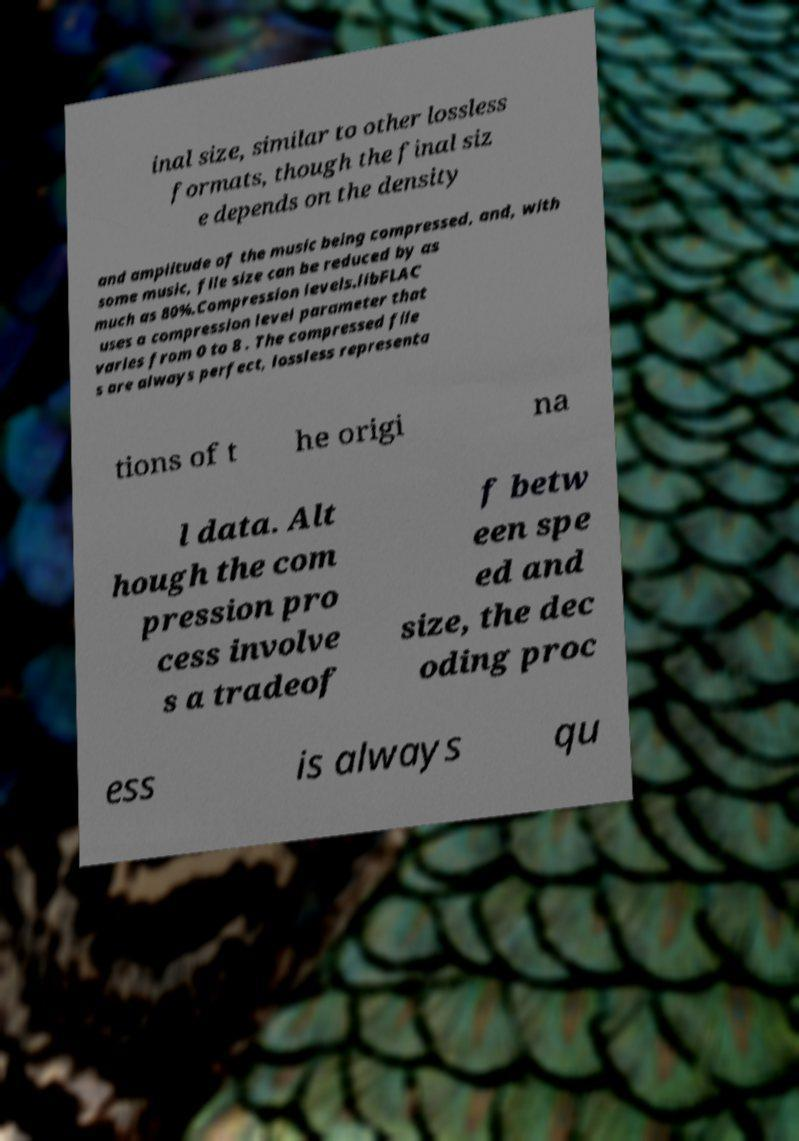I need the written content from this picture converted into text. Can you do that? inal size, similar to other lossless formats, though the final siz e depends on the density and amplitude of the music being compressed, and, with some music, file size can be reduced by as much as 80%.Compression levels.libFLAC uses a compression level parameter that varies from 0 to 8 . The compressed file s are always perfect, lossless representa tions of t he origi na l data. Alt hough the com pression pro cess involve s a tradeof f betw een spe ed and size, the dec oding proc ess is always qu 